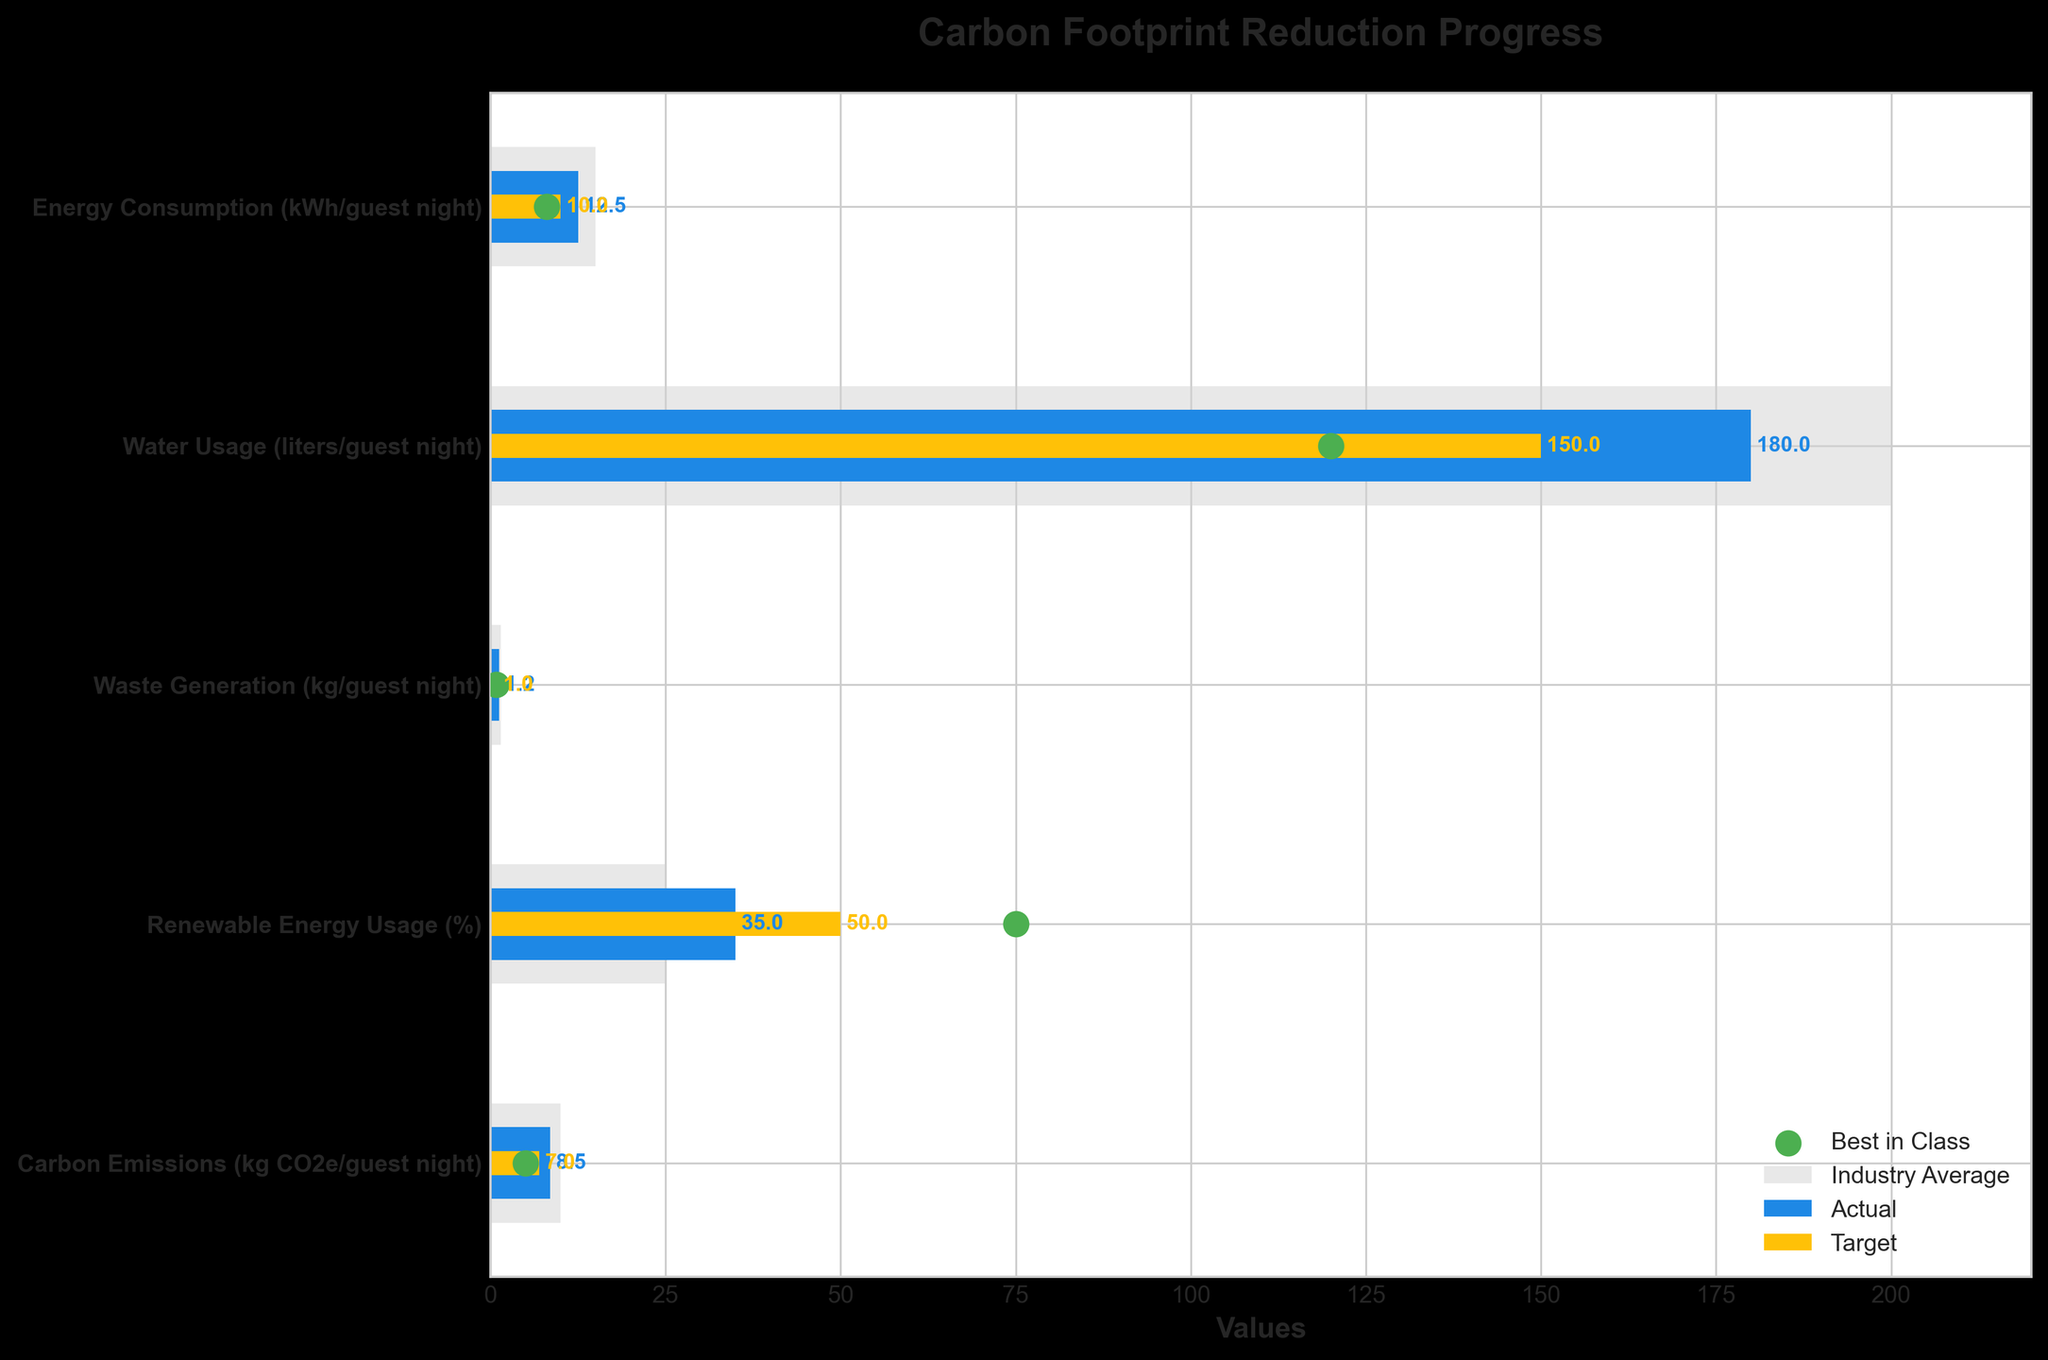What is the title of the figure? The title of the figure is displayed at the top. It reads "Carbon Footprint Reduction Progress".
Answer: Carbon Footprint Reduction Progress What does the blue bar in the chart represent? The blue bar represents the actual values for each category, as indicated in the legend.
Answer: Actual values What is the target value for energy consumption per guest night? The target value for energy consumption per guest night can be found where the yellow bar is marked in the figure, which represents the target. It is 10 kWh/guest night.
Answer: 10 kWh/guest night How does the actual value for waste generation per guest night compare to the target? The actual value for waste generation is shown by the blue bar, and the target is shown by the yellow bar for the same category. The actual value is 1.2 kg/guest night, and the target is 1.0 kg/guest night, so the actual value is greater than the target.
Answer: Greater Which category has the closest actual value to the industry average? By looking at the lengths of the blue bars (actual) and comparing them to the light grey bars (industry average), the carbon emissions category is the closest, with actual at 8.5 kg CO2e/guest night and industry average at 10 kg CO2e/guest night.
Answer: Carbon Emissions What is the most significant difference between the actual value and the best in class for renewable energy usage? For renewable energy usage, best in class is marked by the green dot at 75%, and the actual value is shown by the blue bar at 35%. The difference is 75% - 35% = 40%.
Answer: 40% What category has the best performance when compared to the target? By observing the blue and yellow bars, we see that the closest actual value to the target value is for water usage: actual is 180 liters/guest night and target is 150 liters/guest night. This category still exceeds the target but is closer compared to other categories.
Answer: Water usage In which category are you furthest from achieving the best in class? For each category, find the difference between the blue bar (actual) and the green dot (best in class). The largest difference is seen in Renewable Energy Usage: 75% (best in class) - 35% (actual) = 40%.
Answer: Renewable Energy Usage 